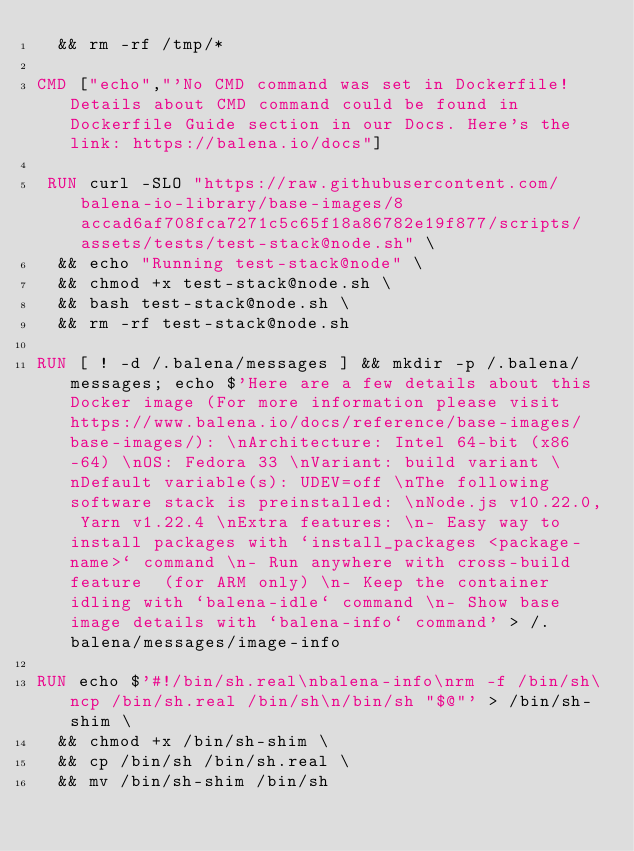<code> <loc_0><loc_0><loc_500><loc_500><_Dockerfile_>	&& rm -rf /tmp/*

CMD ["echo","'No CMD command was set in Dockerfile! Details about CMD command could be found in Dockerfile Guide section in our Docs. Here's the link: https://balena.io/docs"]

 RUN curl -SLO "https://raw.githubusercontent.com/balena-io-library/base-images/8accad6af708fca7271c5c65f18a86782e19f877/scripts/assets/tests/test-stack@node.sh" \
  && echo "Running test-stack@node" \
  && chmod +x test-stack@node.sh \
  && bash test-stack@node.sh \
  && rm -rf test-stack@node.sh 

RUN [ ! -d /.balena/messages ] && mkdir -p /.balena/messages; echo $'Here are a few details about this Docker image (For more information please visit https://www.balena.io/docs/reference/base-images/base-images/): \nArchitecture: Intel 64-bit (x86-64) \nOS: Fedora 33 \nVariant: build variant \nDefault variable(s): UDEV=off \nThe following software stack is preinstalled: \nNode.js v10.22.0, Yarn v1.22.4 \nExtra features: \n- Easy way to install packages with `install_packages <package-name>` command \n- Run anywhere with cross-build feature  (for ARM only) \n- Keep the container idling with `balena-idle` command \n- Show base image details with `balena-info` command' > /.balena/messages/image-info

RUN echo $'#!/bin/sh.real\nbalena-info\nrm -f /bin/sh\ncp /bin/sh.real /bin/sh\n/bin/sh "$@"' > /bin/sh-shim \
	&& chmod +x /bin/sh-shim \
	&& cp /bin/sh /bin/sh.real \
	&& mv /bin/sh-shim /bin/sh</code> 